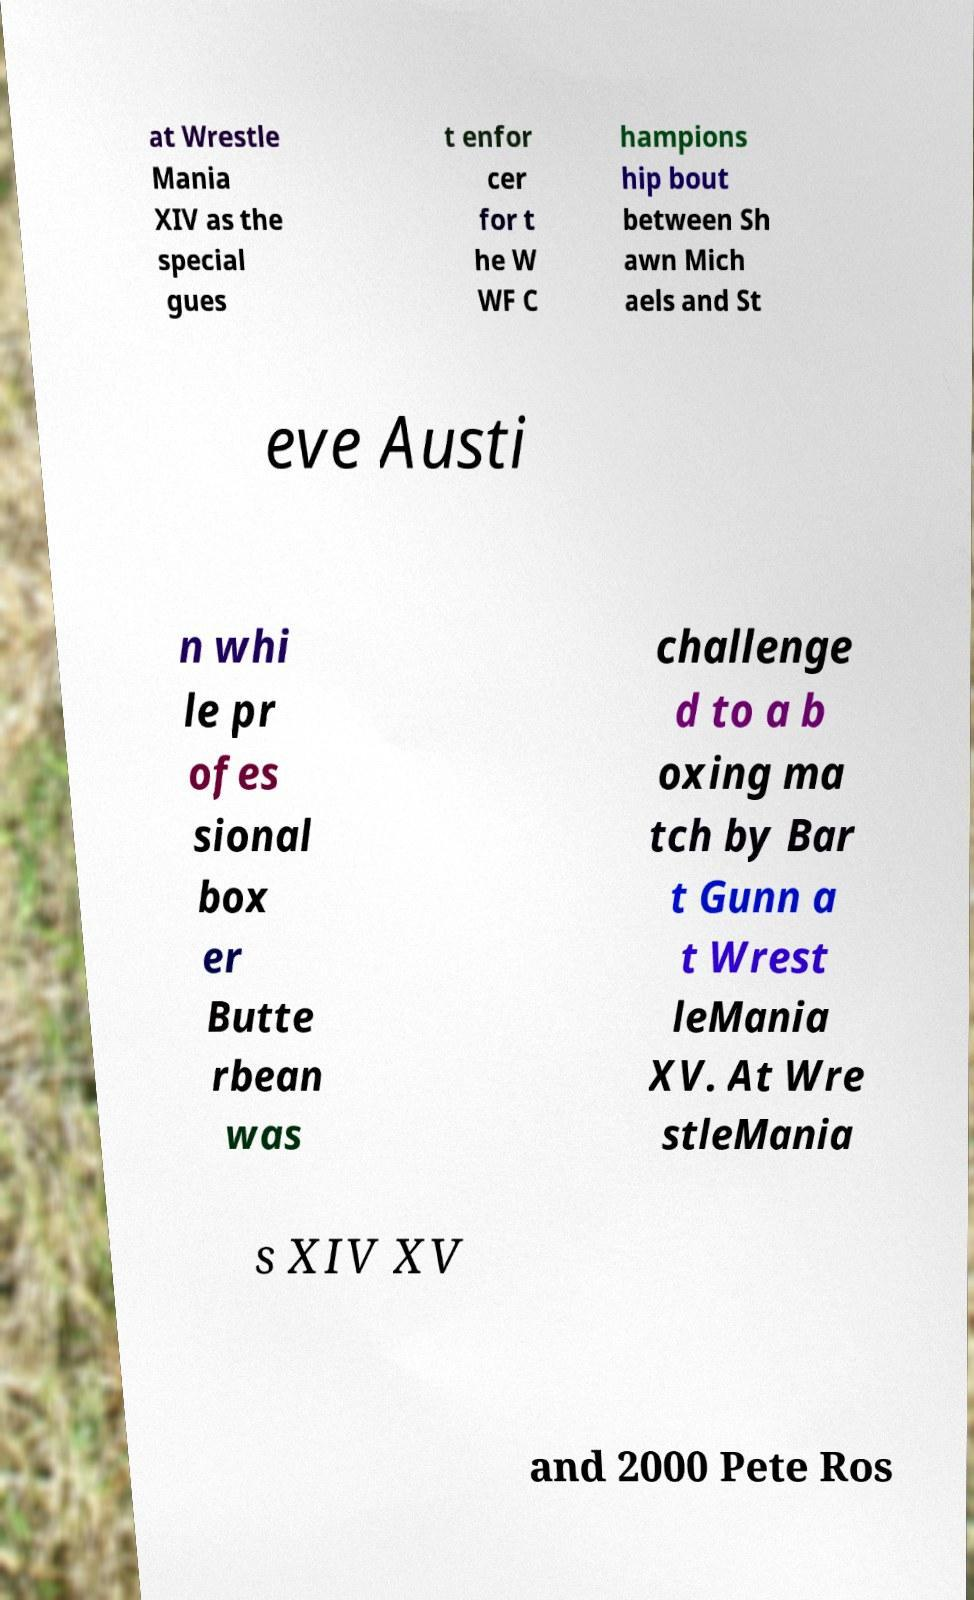For documentation purposes, I need the text within this image transcribed. Could you provide that? at Wrestle Mania XIV as the special gues t enfor cer for t he W WF C hampions hip bout between Sh awn Mich aels and St eve Austi n whi le pr ofes sional box er Butte rbean was challenge d to a b oxing ma tch by Bar t Gunn a t Wrest leMania XV. At Wre stleMania s XIV XV and 2000 Pete Ros 